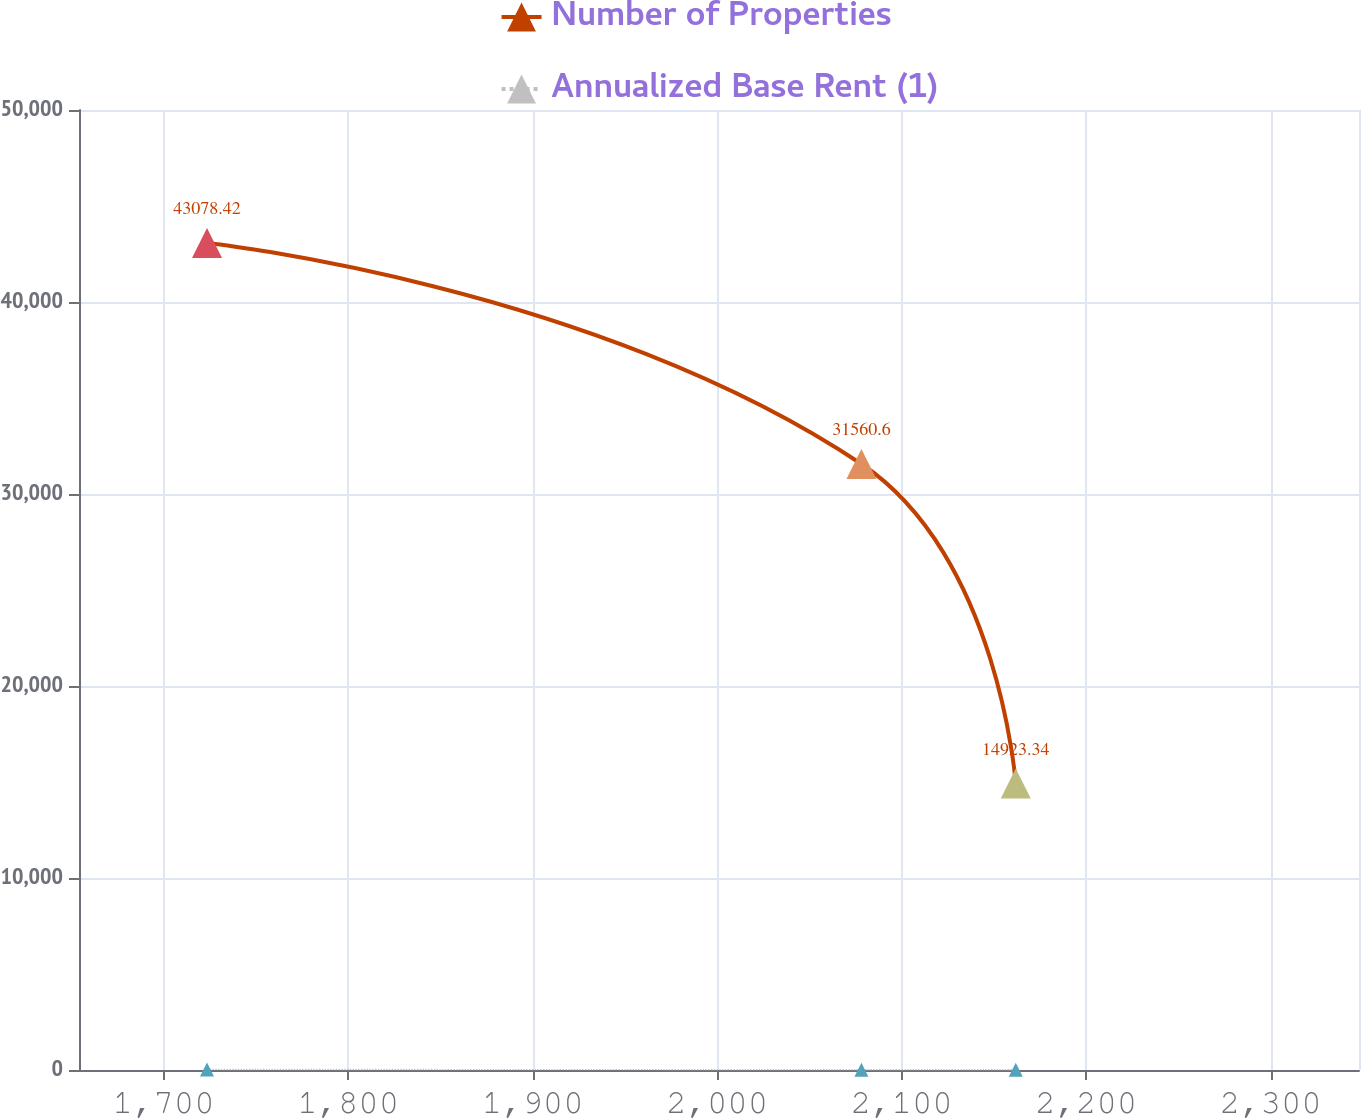<chart> <loc_0><loc_0><loc_500><loc_500><line_chart><ecel><fcel>Number of Properties<fcel>Annualized Base Rent (1)<nl><fcel>1723.51<fcel>43078.4<fcel>27.43<nl><fcel>2078.2<fcel>31560.6<fcel>12.38<nl><fcel>2161.8<fcel>14923.3<fcel>16.88<nl><fcel>2352.96<fcel>38960.2<fcel>19.43<nl><fcel>2417.21<fcel>1815.18<fcel>1.97<nl></chart> 